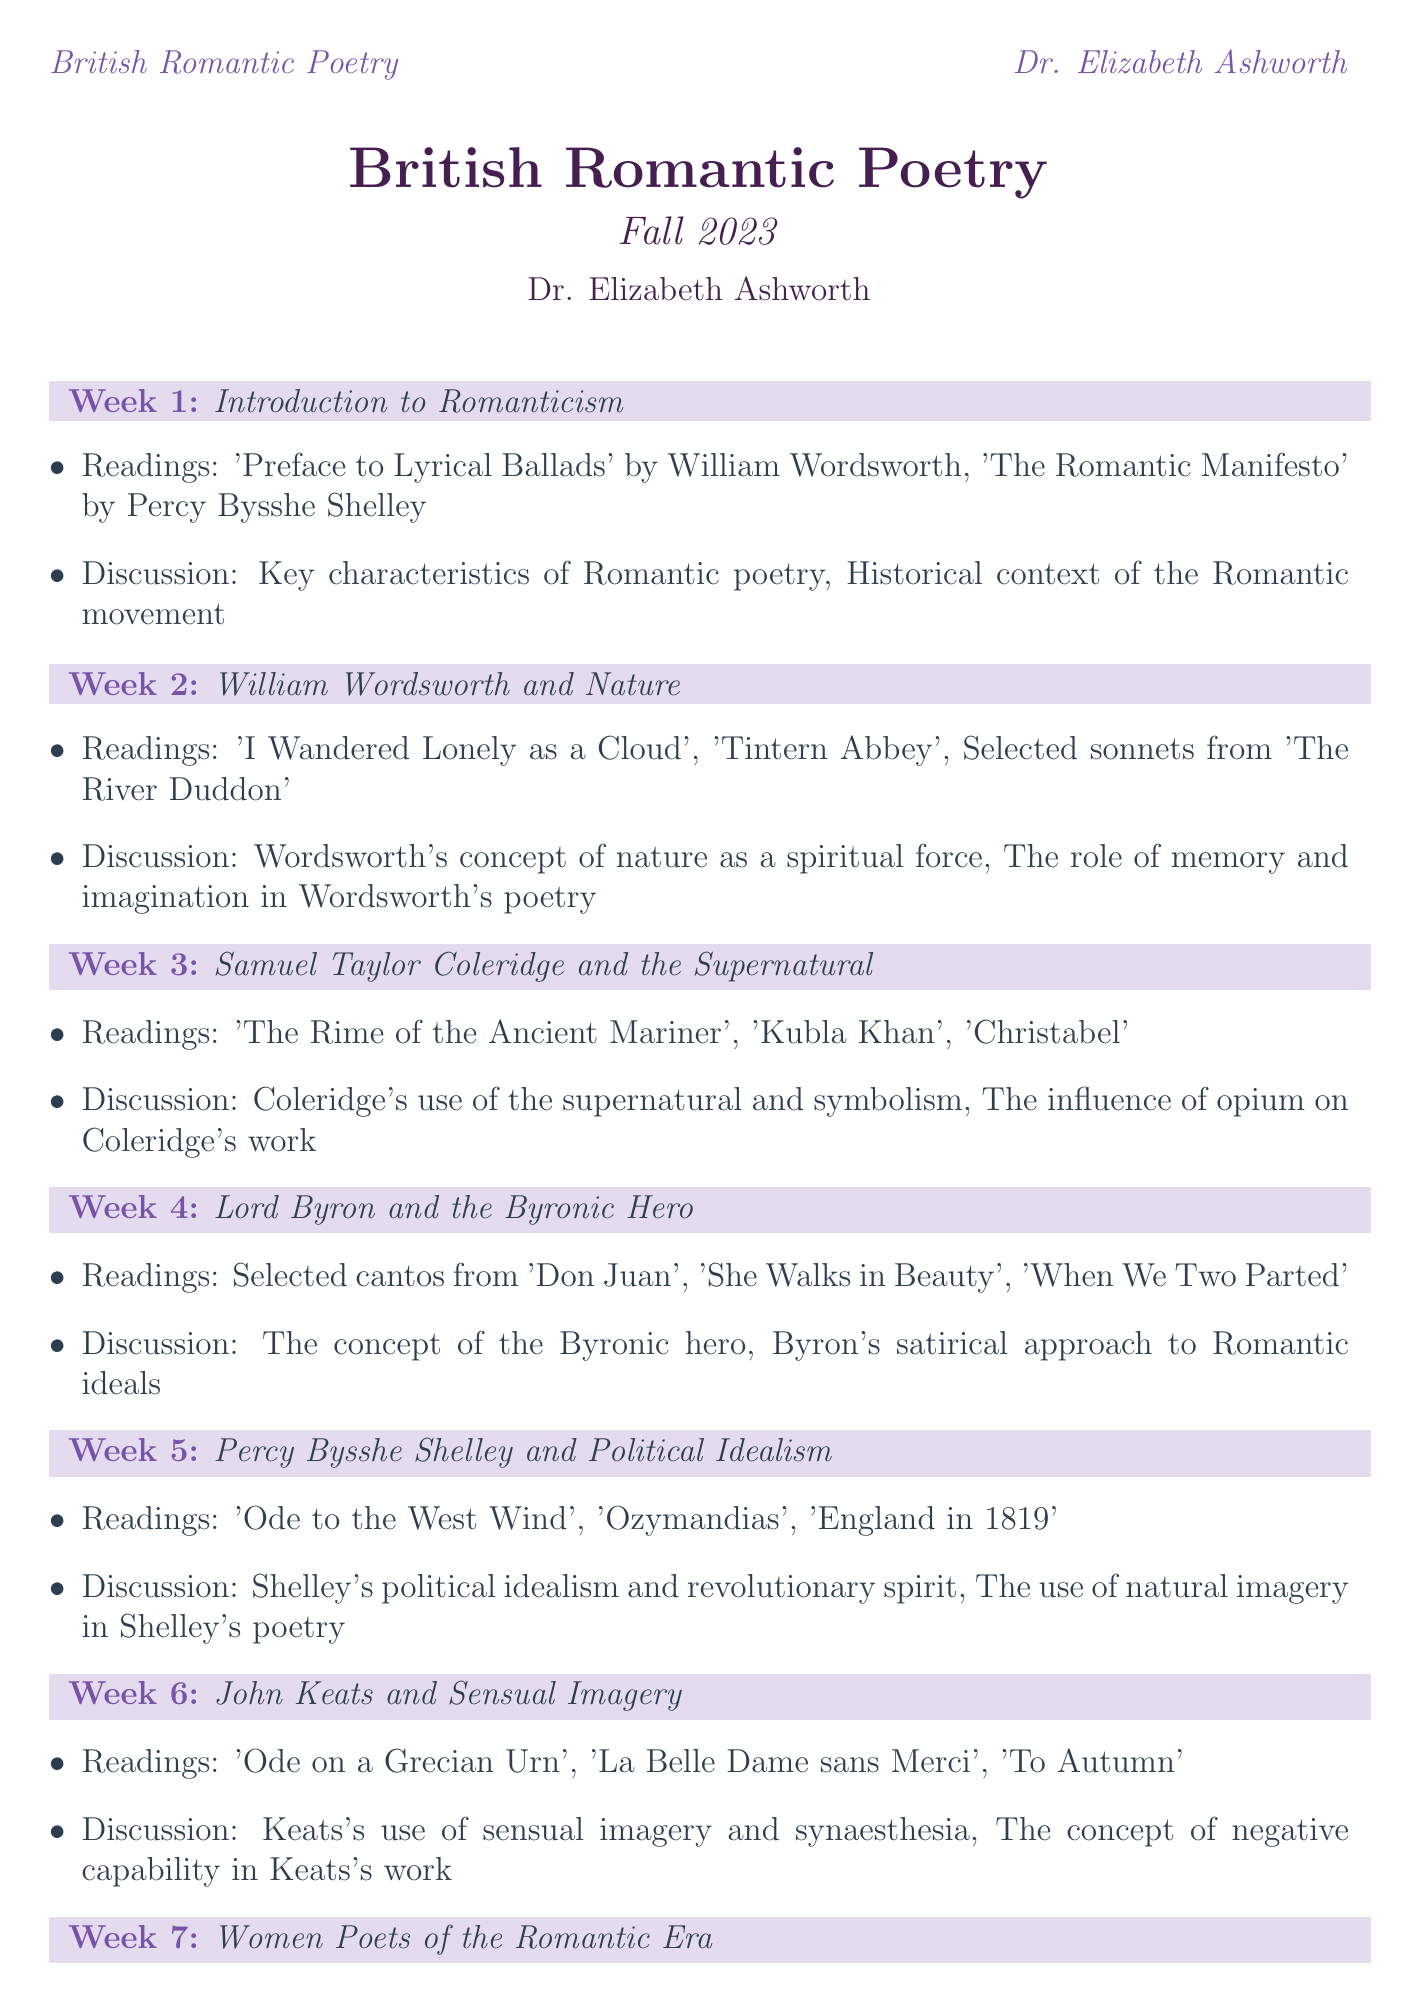What is the course title? The course title is explicitly stated at the beginning of the document.
Answer: British Romantic Poetry Who is the professor of the course? The professor's name is mentioned in the introduction section of the document.
Answer: Dr. Elizabeth Ashworth Which week covers the topic of "Women Poets of the Romantic Era"? The document lists weekly topics in sequential order, making it easy to find the relevant week.
Answer: Week 7 What is the assigned reading for Week 3? Each week has a specific set of readings listed under it, which can be referenced directly.
Answer: 'The Rime of the Ancient Mariner', 'Kubla Khan', 'Christabel' What are the discussion topics for Week 5? Discussion topics for each week are clearly outlined and can be directly obtained from the document.
Answer: Shelley's political idealism and revolutionary spirit, The use of natural imagery in Shelley's poetry Which poet's concept of nature is discussed in Week 2? The topic of the week points out which poet's work is being centered on nature.
Answer: William Wordsworth What is one of the readings for the Gothic in Romantic Poetry? Readings for the Gothic theme are listed separately, making identification straightforward.
Answer: 'The Eve of St. Agnes' by John Keats What is the total number of weeks in the course schedule? The number of weeks can be counted based on the structure of the document showing weekly headers.
Answer: 12 Which reading is revisited in Week 11? The document specifies readings for each week, indicating which texts are revisited.
Answer: 'Kubla Khan' by Samuel Taylor Coleridge (revisited) 